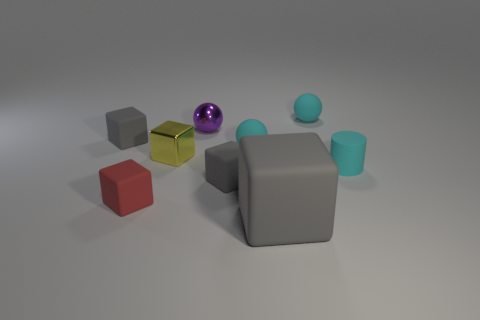What is the red object made of?
Provide a short and direct response. Rubber. What number of metal objects are small yellow blocks or tiny cyan balls?
Your answer should be compact. 1. Are there fewer tiny gray objects to the left of the purple metallic thing than rubber balls in front of the tiny red thing?
Your response must be concise. No. There is a cyan matte ball in front of the matte ball on the right side of the large matte cube; is there a red block that is right of it?
Your answer should be very brief. No. Do the cyan object that is left of the large gray matte cube and the cyan object that is behind the metallic ball have the same shape?
Keep it short and to the point. Yes. There is a yellow block that is the same size as the purple metallic thing; what is it made of?
Offer a terse response. Metal. Do the gray cube that is on the left side of the shiny sphere and the red block in front of the tiny purple shiny object have the same material?
Your answer should be very brief. Yes. The purple metal thing that is the same size as the red rubber cube is what shape?
Your answer should be compact. Sphere. How many other things are there of the same color as the rubber cylinder?
Provide a succinct answer. 2. The small cube that is on the right side of the small purple sphere is what color?
Make the answer very short. Gray. 